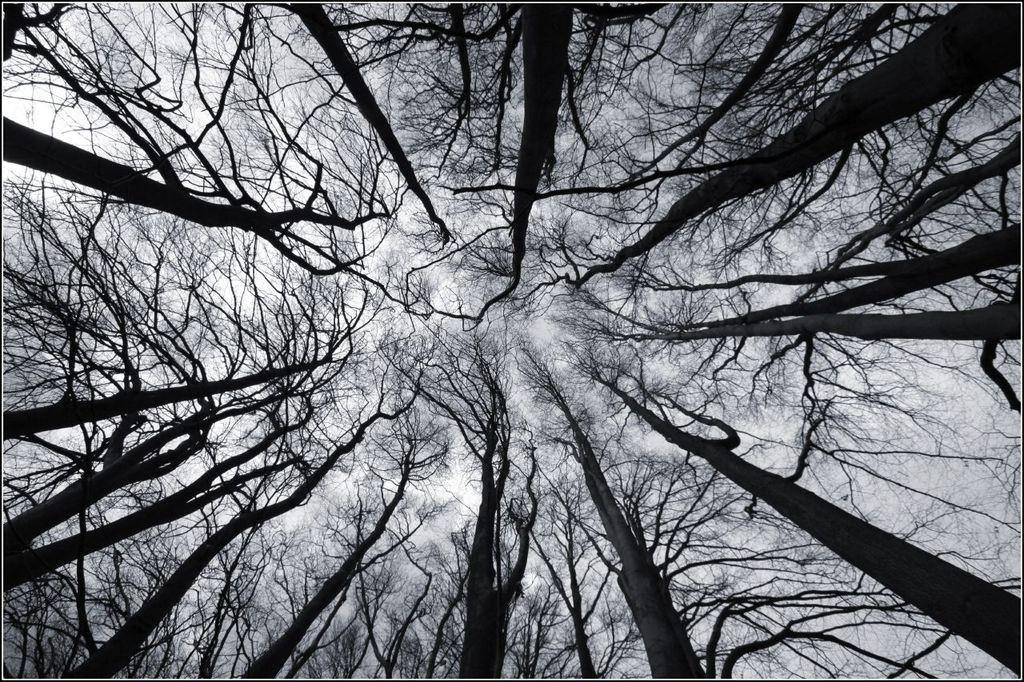What type of vegetation can be seen in the image? There are trees throughout the image. What part of the natural environment is visible in the image? The sky is visible in the background of the image. What type of key is used to make the decision in the image? There is no key or decision-making process depicted in the image; it primarily features trees and the sky. 